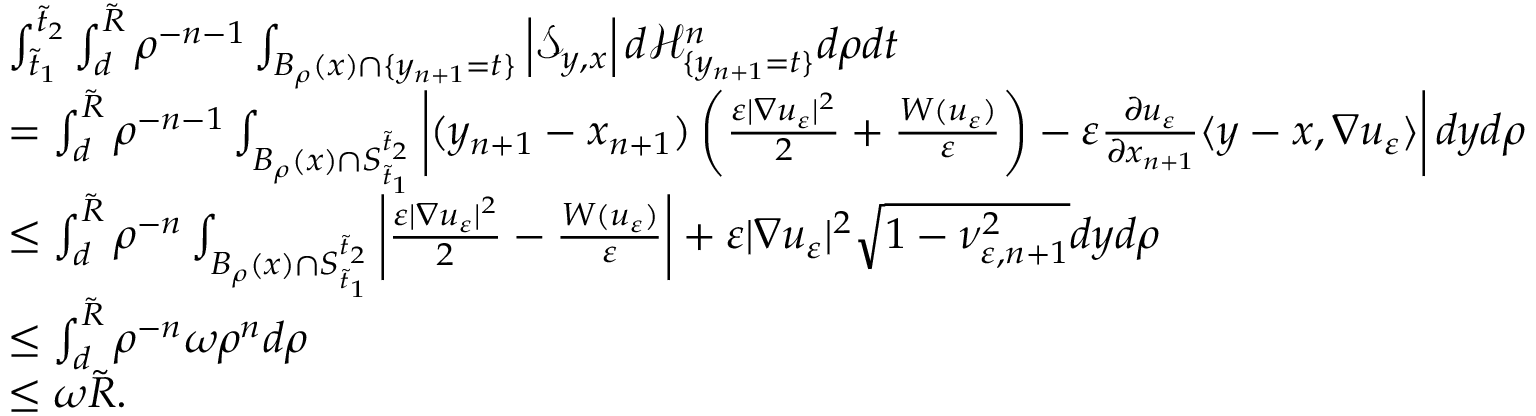<formula> <loc_0><loc_0><loc_500><loc_500>\begin{array} { r l } & { \int _ { \tilde { t } _ { 1 } } ^ { \tilde { t } _ { 2 } } \int _ { d } ^ { \tilde { R } } \rho ^ { - n - 1 } \int _ { B _ { \rho } ( x ) \cap \{ y _ { n + 1 } = t \} } \left | \mathcal { S } _ { y , x } \right | d \mathcal { H } _ { \{ y _ { n + 1 } = t \} } ^ { n } d \rho d t } \\ & { = \int _ { d } ^ { \tilde { R } } \rho ^ { - n - 1 } \int _ { B _ { \rho } ( x ) \cap S _ { \tilde { t } _ { 1 } } ^ { \tilde { t } _ { 2 } } } \left | ( y _ { n + 1 } - x _ { n + 1 } ) \left ( \frac { \varepsilon | \nabla u _ { \varepsilon } | ^ { 2 } } { 2 } + \frac { W ( u _ { \varepsilon } ) } { \varepsilon } \right ) - \varepsilon \frac { \partial u _ { \varepsilon } } { \partial x _ { n + 1 } } \langle y - x , \nabla u _ { \varepsilon } \rangle \right | d y d \rho } \\ & { \leq \int _ { d } ^ { \tilde { R } } \rho ^ { - n } \int _ { B _ { \rho } ( x ) \cap S _ { \tilde { t } _ { 1 } } ^ { \tilde { t } _ { 2 } } } \left | \frac { \varepsilon | \nabla u _ { \varepsilon } | ^ { 2 } } { 2 } - \frac { W ( u _ { \varepsilon } ) } { \varepsilon } \right | + \varepsilon | \nabla u _ { \varepsilon } | ^ { 2 } \sqrt { 1 - \nu _ { \varepsilon , n + 1 } ^ { 2 } } d y d \rho } \\ & { \leq \int _ { d } ^ { \tilde { R } } \rho ^ { - n } \omega \rho ^ { n } d \rho } \\ & { \leq \omega \tilde { R } . } \end{array}</formula> 